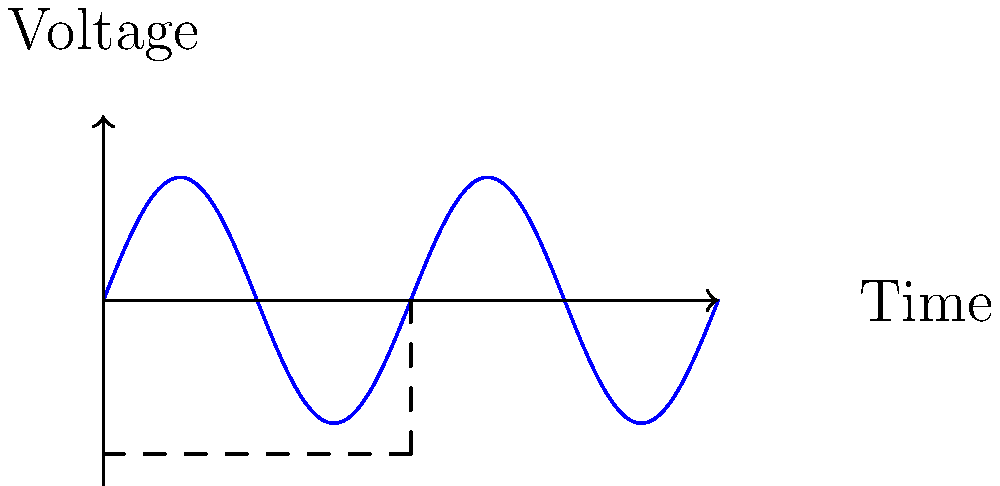In the oscilloscope display shown above, determine the frequency and peak-to-peak amplitude of the sine wave if the time scale is 1 ms/div and the voltage scale is 1 V/div. How might this relate to the rhythmic patterns in Shakespeare's iambic pentameter? Let's break this down step-by-step:

1. Frequency calculation:
   - One complete cycle (period) spans 5 divisions on the time axis
   - Time scale is 1 ms/div
   - Period (T) = 5 div × 1 ms/div = 5 ms
   - Frequency (f) = 1/T = 1/(5 × 10^-3 s) = 200 Hz

2. Amplitude calculation:
   - Peak-to-peak amplitude spans 4 divisions on the voltage axis
   - Voltage scale is 1 V/div
   - Peak-to-peak amplitude = 4 div × 1 V/div = 4 V
   - Peak amplitude (A) = 4 V ÷ 2 = 2 V

3. Relation to Shakespeare:
   The frequency of 200 Hz could be likened to the rhythmic pattern of iambic pentameter in Shakespeare's works. Just as this wave completes 200 cycles per second, iambic pentameter has a consistent rhythm of 10 syllables per line with alternating unstressed and stressed syllables. This regularity in both the wave and the poetic meter creates a pleasing, memorable pattern that resonates with readers and listeners.
Answer: Frequency: 200 Hz, Peak-to-peak amplitude: 4 V 